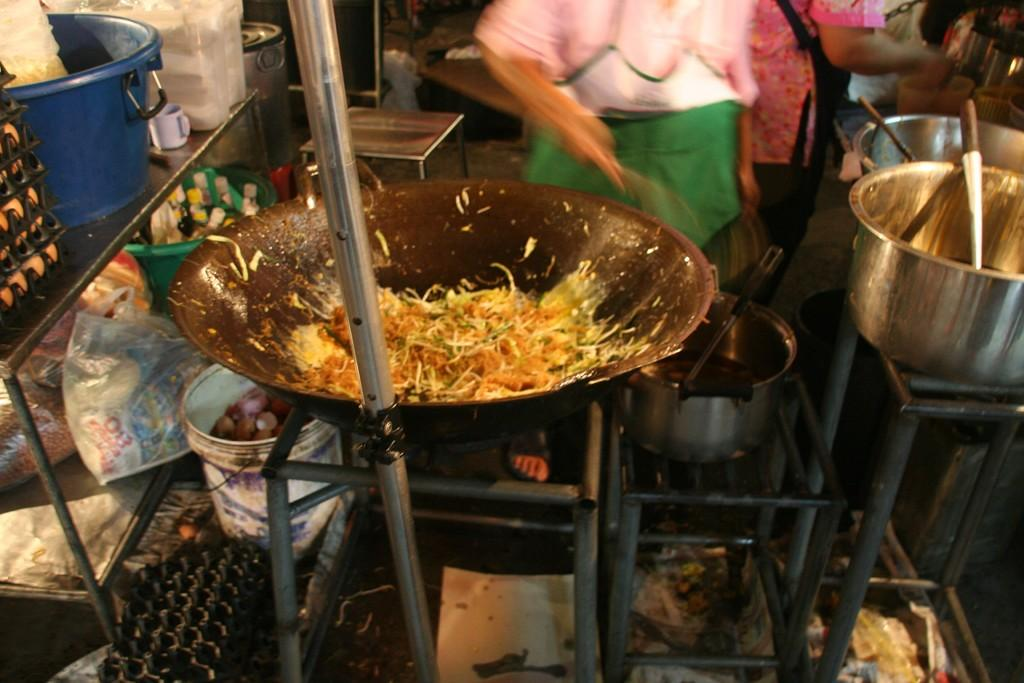What objects can be seen in the image that are used for eating or cooking? There are utensils in the image. What type of food is visible in the image? There is food in the image. What specific ingredient can be seen in the image? There are eggs in the image. Can you describe the person in the image? A person is standing in the image. What type of sidewalk can be seen in the image? There is no sidewalk present in the image. Can you describe the beetle that is crawling on the person's neck in the image? There is no beetle or neck visible in the image. 